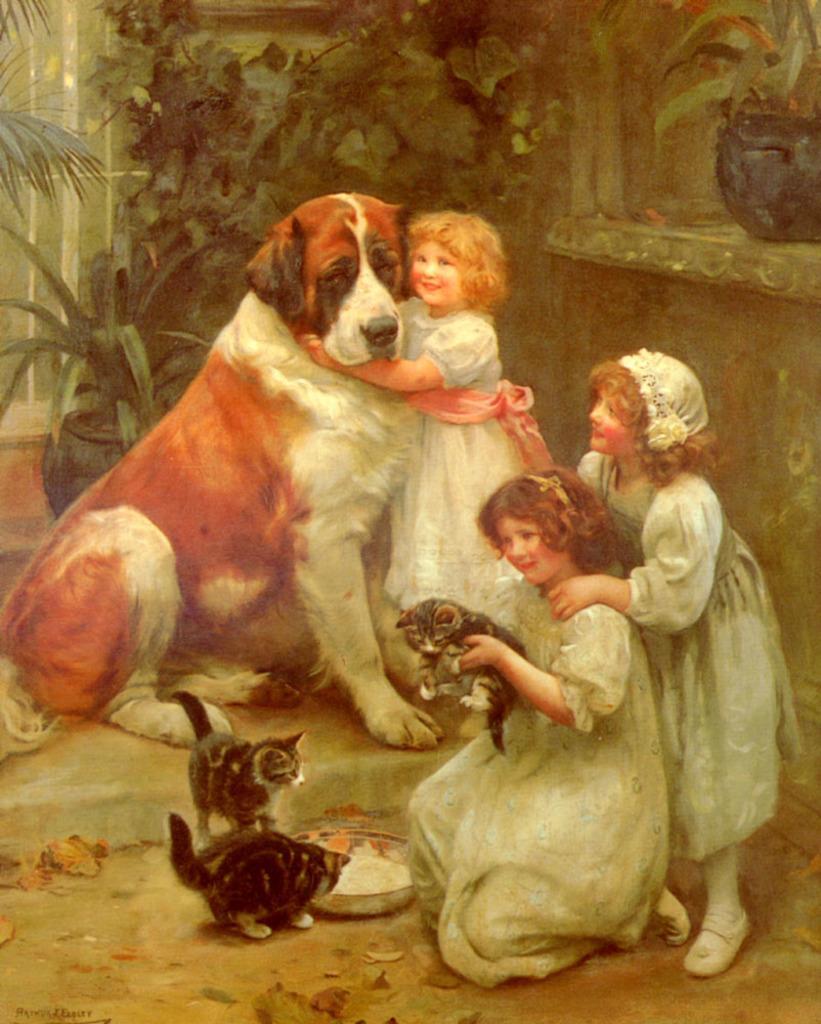Could you give a brief overview of what you see in this image? In this image I can see three persons and I can also see few animals, they are in brown, white and black color. In front the person is wearing white color dress, background I can see few plants in green color and I can also see the glass door. 